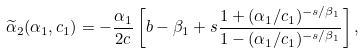Convert formula to latex. <formula><loc_0><loc_0><loc_500><loc_500>\widetilde { \alpha } _ { 2 } ( \alpha _ { 1 } , c _ { 1 } ) = - \frac { \alpha _ { 1 } } { 2 c } \left [ b - \beta _ { 1 } + s \frac { 1 + ( \alpha _ { 1 } / c _ { 1 } ) ^ { - s / \beta _ { 1 } } } { 1 - ( \alpha _ { 1 } / c _ { 1 } ) ^ { - s / \beta _ { 1 } } } \right ] ,</formula> 